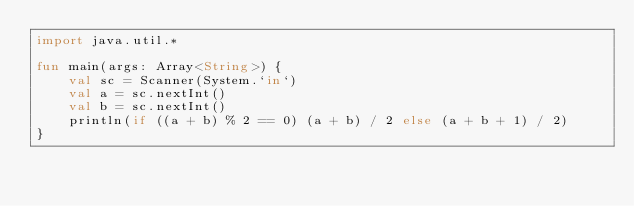<code> <loc_0><loc_0><loc_500><loc_500><_Kotlin_>import java.util.*

fun main(args: Array<String>) {
    val sc = Scanner(System.`in`)
    val a = sc.nextInt()
    val b = sc.nextInt()
    println(if ((a + b) % 2 == 0) (a + b) / 2 else (a + b + 1) / 2)
}</code> 